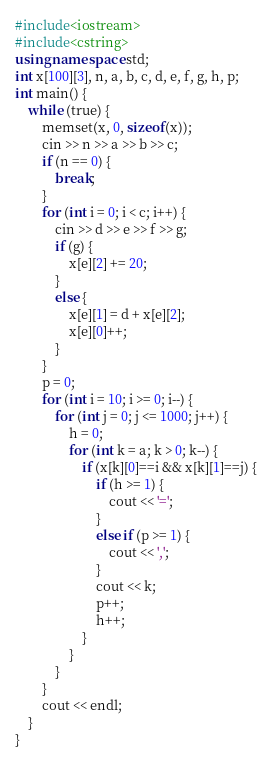<code> <loc_0><loc_0><loc_500><loc_500><_C++_>#include<iostream>
#include<cstring>
using namespace std;
int x[100][3], n, a, b, c, d, e, f, g, h, p;
int main() {
	while (true) {
		memset(x, 0, sizeof(x));
		cin >> n >> a >> b >> c;
		if (n == 0) {
			break;
		}
		for (int i = 0; i < c; i++) {
			cin >> d >> e >> f >> g;
			if (g) {
				x[e][2] += 20;
			}
			else {
				x[e][1] = d + x[e][2];
				x[e][0]++;
			}
		}
		p = 0;
		for (int i = 10; i >= 0; i--) {
			for (int j = 0; j <= 1000; j++) {
				h = 0;
				for (int k = a; k > 0; k--) {
					if (x[k][0]==i && x[k][1]==j) {
						if (h >= 1) {
							cout << '=';
						}
						else if (p >= 1) {
							cout << ',';
						}
						cout << k;
						p++;
						h++;
					}
				}
			}
		}
		cout << endl;
	}
}</code> 